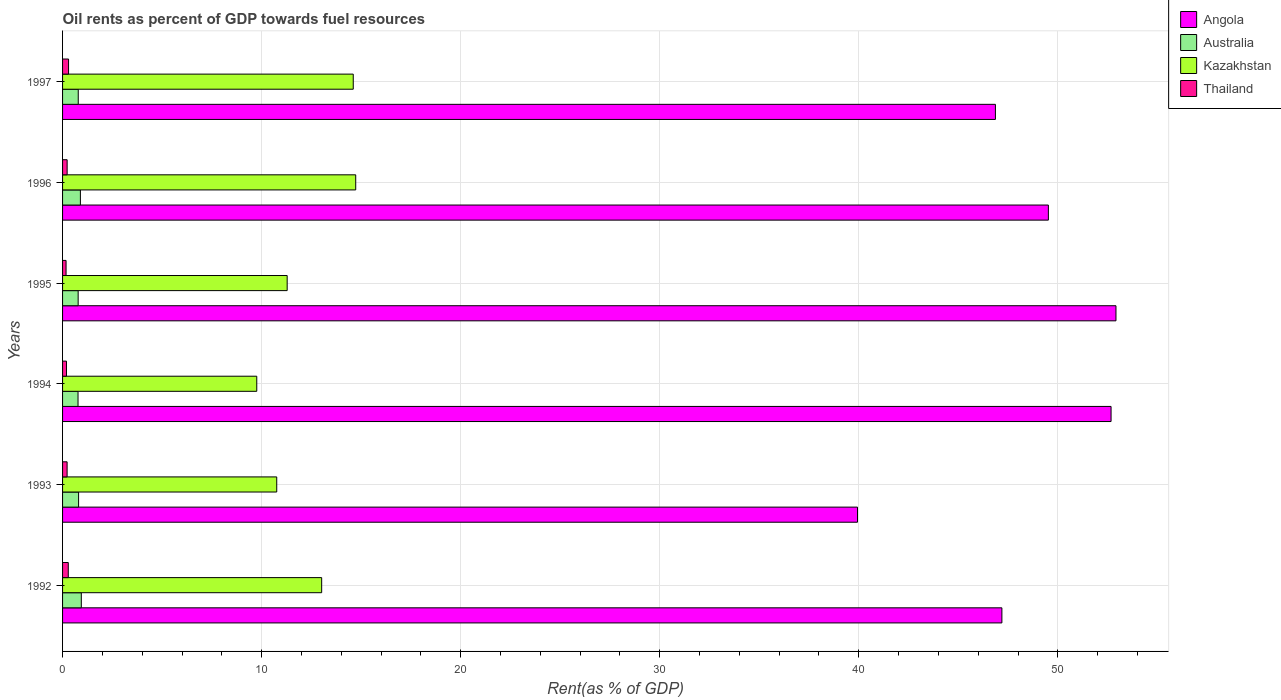How many bars are there on the 1st tick from the bottom?
Offer a very short reply. 4. In how many cases, is the number of bars for a given year not equal to the number of legend labels?
Your answer should be compact. 0. What is the oil rent in Kazakhstan in 1995?
Ensure brevity in your answer.  11.28. Across all years, what is the maximum oil rent in Thailand?
Offer a terse response. 0.3. Across all years, what is the minimum oil rent in Thailand?
Give a very brief answer. 0.18. What is the total oil rent in Thailand in the graph?
Ensure brevity in your answer.  1.42. What is the difference between the oil rent in Australia in 1996 and that in 1997?
Your answer should be compact. 0.11. What is the difference between the oil rent in Thailand in 1993 and the oil rent in Kazakhstan in 1995?
Offer a very short reply. -11.06. What is the average oil rent in Australia per year?
Your response must be concise. 0.83. In the year 1992, what is the difference between the oil rent in Thailand and oil rent in Kazakhstan?
Your answer should be very brief. -12.73. What is the ratio of the oil rent in Angola in 1995 to that in 1996?
Offer a very short reply. 1.07. Is the oil rent in Angola in 1994 less than that in 1995?
Provide a short and direct response. Yes. Is the difference between the oil rent in Thailand in 1994 and 1995 greater than the difference between the oil rent in Kazakhstan in 1994 and 1995?
Ensure brevity in your answer.  Yes. What is the difference between the highest and the second highest oil rent in Thailand?
Provide a succinct answer. 0.01. What is the difference between the highest and the lowest oil rent in Australia?
Your answer should be very brief. 0.16. In how many years, is the oil rent in Kazakhstan greater than the average oil rent in Kazakhstan taken over all years?
Your answer should be very brief. 3. Is the sum of the oil rent in Australia in 1995 and 1997 greater than the maximum oil rent in Angola across all years?
Your response must be concise. No. Is it the case that in every year, the sum of the oil rent in Australia and oil rent in Angola is greater than the sum of oil rent in Thailand and oil rent in Kazakhstan?
Your answer should be compact. Yes. What does the 2nd bar from the top in 1992 represents?
Keep it short and to the point. Kazakhstan. What does the 3rd bar from the bottom in 1994 represents?
Your response must be concise. Kazakhstan. How many bars are there?
Make the answer very short. 24. Are all the bars in the graph horizontal?
Your answer should be very brief. Yes. How many years are there in the graph?
Your answer should be compact. 6. Where does the legend appear in the graph?
Give a very brief answer. Top right. What is the title of the graph?
Provide a short and direct response. Oil rents as percent of GDP towards fuel resources. What is the label or title of the X-axis?
Provide a succinct answer. Rent(as % of GDP). What is the label or title of the Y-axis?
Make the answer very short. Years. What is the Rent(as % of GDP) in Angola in 1992?
Your response must be concise. 47.19. What is the Rent(as % of GDP) in Australia in 1992?
Your answer should be very brief. 0.94. What is the Rent(as % of GDP) of Kazakhstan in 1992?
Keep it short and to the point. 13.02. What is the Rent(as % of GDP) in Thailand in 1992?
Make the answer very short. 0.29. What is the Rent(as % of GDP) of Angola in 1993?
Provide a succinct answer. 39.94. What is the Rent(as % of GDP) of Australia in 1993?
Make the answer very short. 0.81. What is the Rent(as % of GDP) in Kazakhstan in 1993?
Your answer should be very brief. 10.76. What is the Rent(as % of GDP) in Thailand in 1993?
Give a very brief answer. 0.23. What is the Rent(as % of GDP) of Angola in 1994?
Your answer should be very brief. 52.68. What is the Rent(as % of GDP) of Australia in 1994?
Keep it short and to the point. 0.78. What is the Rent(as % of GDP) of Kazakhstan in 1994?
Make the answer very short. 9.76. What is the Rent(as % of GDP) in Thailand in 1994?
Provide a succinct answer. 0.2. What is the Rent(as % of GDP) in Angola in 1995?
Make the answer very short. 52.92. What is the Rent(as % of GDP) in Australia in 1995?
Keep it short and to the point. 0.78. What is the Rent(as % of GDP) in Kazakhstan in 1995?
Provide a short and direct response. 11.28. What is the Rent(as % of GDP) in Thailand in 1995?
Offer a terse response. 0.18. What is the Rent(as % of GDP) of Angola in 1996?
Your answer should be very brief. 49.53. What is the Rent(as % of GDP) of Australia in 1996?
Your response must be concise. 0.9. What is the Rent(as % of GDP) in Kazakhstan in 1996?
Your answer should be compact. 14.73. What is the Rent(as % of GDP) in Thailand in 1996?
Your answer should be compact. 0.23. What is the Rent(as % of GDP) of Angola in 1997?
Make the answer very short. 46.87. What is the Rent(as % of GDP) in Australia in 1997?
Offer a terse response. 0.79. What is the Rent(as % of GDP) in Kazakhstan in 1997?
Provide a short and direct response. 14.6. What is the Rent(as % of GDP) of Thailand in 1997?
Provide a succinct answer. 0.3. Across all years, what is the maximum Rent(as % of GDP) in Angola?
Provide a short and direct response. 52.92. Across all years, what is the maximum Rent(as % of GDP) of Australia?
Ensure brevity in your answer.  0.94. Across all years, what is the maximum Rent(as % of GDP) in Kazakhstan?
Give a very brief answer. 14.73. Across all years, what is the maximum Rent(as % of GDP) in Thailand?
Give a very brief answer. 0.3. Across all years, what is the minimum Rent(as % of GDP) of Angola?
Ensure brevity in your answer.  39.94. Across all years, what is the minimum Rent(as % of GDP) of Australia?
Provide a short and direct response. 0.78. Across all years, what is the minimum Rent(as % of GDP) in Kazakhstan?
Your answer should be compact. 9.76. Across all years, what is the minimum Rent(as % of GDP) in Thailand?
Provide a short and direct response. 0.18. What is the total Rent(as % of GDP) of Angola in the graph?
Keep it short and to the point. 289.11. What is the total Rent(as % of GDP) in Australia in the graph?
Provide a succinct answer. 4.99. What is the total Rent(as % of GDP) of Kazakhstan in the graph?
Provide a short and direct response. 74.15. What is the total Rent(as % of GDP) of Thailand in the graph?
Your answer should be compact. 1.42. What is the difference between the Rent(as % of GDP) of Angola in 1992 and that in 1993?
Offer a very short reply. 7.25. What is the difference between the Rent(as % of GDP) of Australia in 1992 and that in 1993?
Provide a short and direct response. 0.14. What is the difference between the Rent(as % of GDP) in Kazakhstan in 1992 and that in 1993?
Make the answer very short. 2.26. What is the difference between the Rent(as % of GDP) of Thailand in 1992 and that in 1993?
Give a very brief answer. 0.06. What is the difference between the Rent(as % of GDP) of Angola in 1992 and that in 1994?
Ensure brevity in your answer.  -5.48. What is the difference between the Rent(as % of GDP) of Australia in 1992 and that in 1994?
Make the answer very short. 0.16. What is the difference between the Rent(as % of GDP) in Kazakhstan in 1992 and that in 1994?
Provide a succinct answer. 3.26. What is the difference between the Rent(as % of GDP) of Thailand in 1992 and that in 1994?
Offer a very short reply. 0.09. What is the difference between the Rent(as % of GDP) of Angola in 1992 and that in 1995?
Keep it short and to the point. -5.73. What is the difference between the Rent(as % of GDP) of Australia in 1992 and that in 1995?
Provide a succinct answer. 0.16. What is the difference between the Rent(as % of GDP) of Kazakhstan in 1992 and that in 1995?
Provide a short and direct response. 1.73. What is the difference between the Rent(as % of GDP) of Thailand in 1992 and that in 1995?
Keep it short and to the point. 0.11. What is the difference between the Rent(as % of GDP) in Angola in 1992 and that in 1996?
Provide a succinct answer. -2.34. What is the difference between the Rent(as % of GDP) in Australia in 1992 and that in 1996?
Keep it short and to the point. 0.05. What is the difference between the Rent(as % of GDP) in Kazakhstan in 1992 and that in 1996?
Make the answer very short. -1.71. What is the difference between the Rent(as % of GDP) in Thailand in 1992 and that in 1996?
Offer a terse response. 0.06. What is the difference between the Rent(as % of GDP) in Angola in 1992 and that in 1997?
Offer a very short reply. 0.33. What is the difference between the Rent(as % of GDP) in Australia in 1992 and that in 1997?
Your answer should be compact. 0.15. What is the difference between the Rent(as % of GDP) in Kazakhstan in 1992 and that in 1997?
Provide a succinct answer. -1.59. What is the difference between the Rent(as % of GDP) of Thailand in 1992 and that in 1997?
Your response must be concise. -0.01. What is the difference between the Rent(as % of GDP) in Angola in 1993 and that in 1994?
Your answer should be very brief. -12.74. What is the difference between the Rent(as % of GDP) of Australia in 1993 and that in 1994?
Give a very brief answer. 0.03. What is the difference between the Rent(as % of GDP) in Thailand in 1993 and that in 1994?
Ensure brevity in your answer.  0.03. What is the difference between the Rent(as % of GDP) of Angola in 1993 and that in 1995?
Ensure brevity in your answer.  -12.98. What is the difference between the Rent(as % of GDP) in Australia in 1993 and that in 1995?
Offer a terse response. 0.02. What is the difference between the Rent(as % of GDP) of Kazakhstan in 1993 and that in 1995?
Provide a succinct answer. -0.52. What is the difference between the Rent(as % of GDP) in Thailand in 1993 and that in 1995?
Make the answer very short. 0.05. What is the difference between the Rent(as % of GDP) in Angola in 1993 and that in 1996?
Provide a short and direct response. -9.59. What is the difference between the Rent(as % of GDP) of Australia in 1993 and that in 1996?
Ensure brevity in your answer.  -0.09. What is the difference between the Rent(as % of GDP) of Kazakhstan in 1993 and that in 1996?
Your answer should be compact. -3.97. What is the difference between the Rent(as % of GDP) in Thailand in 1993 and that in 1996?
Offer a terse response. -0. What is the difference between the Rent(as % of GDP) in Angola in 1993 and that in 1997?
Your answer should be very brief. -6.93. What is the difference between the Rent(as % of GDP) of Australia in 1993 and that in 1997?
Offer a terse response. 0.02. What is the difference between the Rent(as % of GDP) of Kazakhstan in 1993 and that in 1997?
Give a very brief answer. -3.84. What is the difference between the Rent(as % of GDP) in Thailand in 1993 and that in 1997?
Keep it short and to the point. -0.07. What is the difference between the Rent(as % of GDP) of Angola in 1994 and that in 1995?
Provide a succinct answer. -0.25. What is the difference between the Rent(as % of GDP) in Australia in 1994 and that in 1995?
Ensure brevity in your answer.  -0.01. What is the difference between the Rent(as % of GDP) in Kazakhstan in 1994 and that in 1995?
Give a very brief answer. -1.53. What is the difference between the Rent(as % of GDP) of Thailand in 1994 and that in 1995?
Provide a short and direct response. 0.02. What is the difference between the Rent(as % of GDP) in Angola in 1994 and that in 1996?
Provide a succinct answer. 3.15. What is the difference between the Rent(as % of GDP) of Australia in 1994 and that in 1996?
Make the answer very short. -0.12. What is the difference between the Rent(as % of GDP) in Kazakhstan in 1994 and that in 1996?
Keep it short and to the point. -4.97. What is the difference between the Rent(as % of GDP) of Thailand in 1994 and that in 1996?
Keep it short and to the point. -0.03. What is the difference between the Rent(as % of GDP) in Angola in 1994 and that in 1997?
Offer a very short reply. 5.81. What is the difference between the Rent(as % of GDP) of Australia in 1994 and that in 1997?
Keep it short and to the point. -0.01. What is the difference between the Rent(as % of GDP) of Kazakhstan in 1994 and that in 1997?
Give a very brief answer. -4.85. What is the difference between the Rent(as % of GDP) of Thailand in 1994 and that in 1997?
Your response must be concise. -0.1. What is the difference between the Rent(as % of GDP) of Angola in 1995 and that in 1996?
Your answer should be compact. 3.4. What is the difference between the Rent(as % of GDP) in Australia in 1995 and that in 1996?
Your answer should be very brief. -0.11. What is the difference between the Rent(as % of GDP) of Kazakhstan in 1995 and that in 1996?
Your answer should be compact. -3.44. What is the difference between the Rent(as % of GDP) in Thailand in 1995 and that in 1996?
Ensure brevity in your answer.  -0.05. What is the difference between the Rent(as % of GDP) in Angola in 1995 and that in 1997?
Offer a very short reply. 6.06. What is the difference between the Rent(as % of GDP) in Australia in 1995 and that in 1997?
Offer a terse response. -0. What is the difference between the Rent(as % of GDP) in Kazakhstan in 1995 and that in 1997?
Make the answer very short. -3.32. What is the difference between the Rent(as % of GDP) of Thailand in 1995 and that in 1997?
Give a very brief answer. -0.13. What is the difference between the Rent(as % of GDP) in Angola in 1996 and that in 1997?
Provide a succinct answer. 2.66. What is the difference between the Rent(as % of GDP) in Australia in 1996 and that in 1997?
Provide a succinct answer. 0.11. What is the difference between the Rent(as % of GDP) of Kazakhstan in 1996 and that in 1997?
Your answer should be compact. 0.12. What is the difference between the Rent(as % of GDP) in Thailand in 1996 and that in 1997?
Make the answer very short. -0.07. What is the difference between the Rent(as % of GDP) in Angola in 1992 and the Rent(as % of GDP) in Australia in 1993?
Provide a succinct answer. 46.39. What is the difference between the Rent(as % of GDP) of Angola in 1992 and the Rent(as % of GDP) of Kazakhstan in 1993?
Your answer should be compact. 36.43. What is the difference between the Rent(as % of GDP) in Angola in 1992 and the Rent(as % of GDP) in Thailand in 1993?
Your answer should be compact. 46.96. What is the difference between the Rent(as % of GDP) of Australia in 1992 and the Rent(as % of GDP) of Kazakhstan in 1993?
Your response must be concise. -9.82. What is the difference between the Rent(as % of GDP) of Australia in 1992 and the Rent(as % of GDP) of Thailand in 1993?
Your answer should be very brief. 0.71. What is the difference between the Rent(as % of GDP) of Kazakhstan in 1992 and the Rent(as % of GDP) of Thailand in 1993?
Your answer should be compact. 12.79. What is the difference between the Rent(as % of GDP) of Angola in 1992 and the Rent(as % of GDP) of Australia in 1994?
Offer a terse response. 46.41. What is the difference between the Rent(as % of GDP) in Angola in 1992 and the Rent(as % of GDP) in Kazakhstan in 1994?
Your response must be concise. 37.43. What is the difference between the Rent(as % of GDP) in Angola in 1992 and the Rent(as % of GDP) in Thailand in 1994?
Provide a succinct answer. 46.99. What is the difference between the Rent(as % of GDP) in Australia in 1992 and the Rent(as % of GDP) in Kazakhstan in 1994?
Offer a terse response. -8.81. What is the difference between the Rent(as % of GDP) in Australia in 1992 and the Rent(as % of GDP) in Thailand in 1994?
Your response must be concise. 0.74. What is the difference between the Rent(as % of GDP) of Kazakhstan in 1992 and the Rent(as % of GDP) of Thailand in 1994?
Your answer should be very brief. 12.82. What is the difference between the Rent(as % of GDP) of Angola in 1992 and the Rent(as % of GDP) of Australia in 1995?
Offer a very short reply. 46.41. What is the difference between the Rent(as % of GDP) in Angola in 1992 and the Rent(as % of GDP) in Kazakhstan in 1995?
Provide a short and direct response. 35.91. What is the difference between the Rent(as % of GDP) of Angola in 1992 and the Rent(as % of GDP) of Thailand in 1995?
Provide a succinct answer. 47.02. What is the difference between the Rent(as % of GDP) in Australia in 1992 and the Rent(as % of GDP) in Kazakhstan in 1995?
Your answer should be compact. -10.34. What is the difference between the Rent(as % of GDP) of Australia in 1992 and the Rent(as % of GDP) of Thailand in 1995?
Offer a terse response. 0.77. What is the difference between the Rent(as % of GDP) in Kazakhstan in 1992 and the Rent(as % of GDP) in Thailand in 1995?
Provide a short and direct response. 12.84. What is the difference between the Rent(as % of GDP) of Angola in 1992 and the Rent(as % of GDP) of Australia in 1996?
Provide a succinct answer. 46.29. What is the difference between the Rent(as % of GDP) in Angola in 1992 and the Rent(as % of GDP) in Kazakhstan in 1996?
Provide a short and direct response. 32.46. What is the difference between the Rent(as % of GDP) of Angola in 1992 and the Rent(as % of GDP) of Thailand in 1996?
Ensure brevity in your answer.  46.96. What is the difference between the Rent(as % of GDP) of Australia in 1992 and the Rent(as % of GDP) of Kazakhstan in 1996?
Provide a short and direct response. -13.79. What is the difference between the Rent(as % of GDP) of Australia in 1992 and the Rent(as % of GDP) of Thailand in 1996?
Provide a short and direct response. 0.71. What is the difference between the Rent(as % of GDP) of Kazakhstan in 1992 and the Rent(as % of GDP) of Thailand in 1996?
Give a very brief answer. 12.79. What is the difference between the Rent(as % of GDP) of Angola in 1992 and the Rent(as % of GDP) of Australia in 1997?
Offer a very short reply. 46.4. What is the difference between the Rent(as % of GDP) in Angola in 1992 and the Rent(as % of GDP) in Kazakhstan in 1997?
Your answer should be compact. 32.59. What is the difference between the Rent(as % of GDP) in Angola in 1992 and the Rent(as % of GDP) in Thailand in 1997?
Offer a terse response. 46.89. What is the difference between the Rent(as % of GDP) in Australia in 1992 and the Rent(as % of GDP) in Kazakhstan in 1997?
Ensure brevity in your answer.  -13.66. What is the difference between the Rent(as % of GDP) of Australia in 1992 and the Rent(as % of GDP) of Thailand in 1997?
Make the answer very short. 0.64. What is the difference between the Rent(as % of GDP) of Kazakhstan in 1992 and the Rent(as % of GDP) of Thailand in 1997?
Provide a succinct answer. 12.72. What is the difference between the Rent(as % of GDP) in Angola in 1993 and the Rent(as % of GDP) in Australia in 1994?
Your response must be concise. 39.16. What is the difference between the Rent(as % of GDP) of Angola in 1993 and the Rent(as % of GDP) of Kazakhstan in 1994?
Ensure brevity in your answer.  30.18. What is the difference between the Rent(as % of GDP) of Angola in 1993 and the Rent(as % of GDP) of Thailand in 1994?
Your answer should be compact. 39.74. What is the difference between the Rent(as % of GDP) in Australia in 1993 and the Rent(as % of GDP) in Kazakhstan in 1994?
Make the answer very short. -8.95. What is the difference between the Rent(as % of GDP) in Australia in 1993 and the Rent(as % of GDP) in Thailand in 1994?
Ensure brevity in your answer.  0.61. What is the difference between the Rent(as % of GDP) of Kazakhstan in 1993 and the Rent(as % of GDP) of Thailand in 1994?
Keep it short and to the point. 10.56. What is the difference between the Rent(as % of GDP) of Angola in 1993 and the Rent(as % of GDP) of Australia in 1995?
Your answer should be very brief. 39.15. What is the difference between the Rent(as % of GDP) of Angola in 1993 and the Rent(as % of GDP) of Kazakhstan in 1995?
Keep it short and to the point. 28.65. What is the difference between the Rent(as % of GDP) in Angola in 1993 and the Rent(as % of GDP) in Thailand in 1995?
Ensure brevity in your answer.  39.76. What is the difference between the Rent(as % of GDP) of Australia in 1993 and the Rent(as % of GDP) of Kazakhstan in 1995?
Ensure brevity in your answer.  -10.48. What is the difference between the Rent(as % of GDP) in Australia in 1993 and the Rent(as % of GDP) in Thailand in 1995?
Your response must be concise. 0.63. What is the difference between the Rent(as % of GDP) of Kazakhstan in 1993 and the Rent(as % of GDP) of Thailand in 1995?
Your response must be concise. 10.58. What is the difference between the Rent(as % of GDP) in Angola in 1993 and the Rent(as % of GDP) in Australia in 1996?
Provide a short and direct response. 39.04. What is the difference between the Rent(as % of GDP) in Angola in 1993 and the Rent(as % of GDP) in Kazakhstan in 1996?
Your answer should be very brief. 25.21. What is the difference between the Rent(as % of GDP) in Angola in 1993 and the Rent(as % of GDP) in Thailand in 1996?
Keep it short and to the point. 39.71. What is the difference between the Rent(as % of GDP) in Australia in 1993 and the Rent(as % of GDP) in Kazakhstan in 1996?
Offer a very short reply. -13.92. What is the difference between the Rent(as % of GDP) of Australia in 1993 and the Rent(as % of GDP) of Thailand in 1996?
Ensure brevity in your answer.  0.57. What is the difference between the Rent(as % of GDP) of Kazakhstan in 1993 and the Rent(as % of GDP) of Thailand in 1996?
Your response must be concise. 10.53. What is the difference between the Rent(as % of GDP) of Angola in 1993 and the Rent(as % of GDP) of Australia in 1997?
Provide a short and direct response. 39.15. What is the difference between the Rent(as % of GDP) of Angola in 1993 and the Rent(as % of GDP) of Kazakhstan in 1997?
Make the answer very short. 25.33. What is the difference between the Rent(as % of GDP) of Angola in 1993 and the Rent(as % of GDP) of Thailand in 1997?
Your response must be concise. 39.64. What is the difference between the Rent(as % of GDP) in Australia in 1993 and the Rent(as % of GDP) in Kazakhstan in 1997?
Ensure brevity in your answer.  -13.8. What is the difference between the Rent(as % of GDP) of Australia in 1993 and the Rent(as % of GDP) of Thailand in 1997?
Give a very brief answer. 0.5. What is the difference between the Rent(as % of GDP) in Kazakhstan in 1993 and the Rent(as % of GDP) in Thailand in 1997?
Make the answer very short. 10.46. What is the difference between the Rent(as % of GDP) in Angola in 1994 and the Rent(as % of GDP) in Australia in 1995?
Offer a terse response. 51.89. What is the difference between the Rent(as % of GDP) of Angola in 1994 and the Rent(as % of GDP) of Kazakhstan in 1995?
Make the answer very short. 41.39. What is the difference between the Rent(as % of GDP) of Angola in 1994 and the Rent(as % of GDP) of Thailand in 1995?
Your answer should be very brief. 52.5. What is the difference between the Rent(as % of GDP) of Australia in 1994 and the Rent(as % of GDP) of Kazakhstan in 1995?
Your answer should be compact. -10.51. What is the difference between the Rent(as % of GDP) of Australia in 1994 and the Rent(as % of GDP) of Thailand in 1995?
Your response must be concise. 0.6. What is the difference between the Rent(as % of GDP) in Kazakhstan in 1994 and the Rent(as % of GDP) in Thailand in 1995?
Your answer should be compact. 9.58. What is the difference between the Rent(as % of GDP) in Angola in 1994 and the Rent(as % of GDP) in Australia in 1996?
Provide a short and direct response. 51.78. What is the difference between the Rent(as % of GDP) in Angola in 1994 and the Rent(as % of GDP) in Kazakhstan in 1996?
Provide a succinct answer. 37.95. What is the difference between the Rent(as % of GDP) of Angola in 1994 and the Rent(as % of GDP) of Thailand in 1996?
Ensure brevity in your answer.  52.45. What is the difference between the Rent(as % of GDP) of Australia in 1994 and the Rent(as % of GDP) of Kazakhstan in 1996?
Keep it short and to the point. -13.95. What is the difference between the Rent(as % of GDP) of Australia in 1994 and the Rent(as % of GDP) of Thailand in 1996?
Keep it short and to the point. 0.55. What is the difference between the Rent(as % of GDP) in Kazakhstan in 1994 and the Rent(as % of GDP) in Thailand in 1996?
Make the answer very short. 9.53. What is the difference between the Rent(as % of GDP) of Angola in 1994 and the Rent(as % of GDP) of Australia in 1997?
Offer a very short reply. 51.89. What is the difference between the Rent(as % of GDP) of Angola in 1994 and the Rent(as % of GDP) of Kazakhstan in 1997?
Your answer should be very brief. 38.07. What is the difference between the Rent(as % of GDP) of Angola in 1994 and the Rent(as % of GDP) of Thailand in 1997?
Your response must be concise. 52.37. What is the difference between the Rent(as % of GDP) of Australia in 1994 and the Rent(as % of GDP) of Kazakhstan in 1997?
Offer a terse response. -13.83. What is the difference between the Rent(as % of GDP) in Australia in 1994 and the Rent(as % of GDP) in Thailand in 1997?
Your answer should be compact. 0.48. What is the difference between the Rent(as % of GDP) of Kazakhstan in 1994 and the Rent(as % of GDP) of Thailand in 1997?
Ensure brevity in your answer.  9.46. What is the difference between the Rent(as % of GDP) of Angola in 1995 and the Rent(as % of GDP) of Australia in 1996?
Keep it short and to the point. 52.03. What is the difference between the Rent(as % of GDP) in Angola in 1995 and the Rent(as % of GDP) in Kazakhstan in 1996?
Keep it short and to the point. 38.19. What is the difference between the Rent(as % of GDP) in Angola in 1995 and the Rent(as % of GDP) in Thailand in 1996?
Keep it short and to the point. 52.69. What is the difference between the Rent(as % of GDP) of Australia in 1995 and the Rent(as % of GDP) of Kazakhstan in 1996?
Keep it short and to the point. -13.94. What is the difference between the Rent(as % of GDP) in Australia in 1995 and the Rent(as % of GDP) in Thailand in 1996?
Your answer should be very brief. 0.55. What is the difference between the Rent(as % of GDP) of Kazakhstan in 1995 and the Rent(as % of GDP) of Thailand in 1996?
Offer a very short reply. 11.05. What is the difference between the Rent(as % of GDP) of Angola in 1995 and the Rent(as % of GDP) of Australia in 1997?
Keep it short and to the point. 52.13. What is the difference between the Rent(as % of GDP) in Angola in 1995 and the Rent(as % of GDP) in Kazakhstan in 1997?
Make the answer very short. 38.32. What is the difference between the Rent(as % of GDP) of Angola in 1995 and the Rent(as % of GDP) of Thailand in 1997?
Your answer should be very brief. 52.62. What is the difference between the Rent(as % of GDP) of Australia in 1995 and the Rent(as % of GDP) of Kazakhstan in 1997?
Keep it short and to the point. -13.82. What is the difference between the Rent(as % of GDP) in Australia in 1995 and the Rent(as % of GDP) in Thailand in 1997?
Your answer should be very brief. 0.48. What is the difference between the Rent(as % of GDP) in Kazakhstan in 1995 and the Rent(as % of GDP) in Thailand in 1997?
Keep it short and to the point. 10.98. What is the difference between the Rent(as % of GDP) in Angola in 1996 and the Rent(as % of GDP) in Australia in 1997?
Offer a terse response. 48.74. What is the difference between the Rent(as % of GDP) of Angola in 1996 and the Rent(as % of GDP) of Kazakhstan in 1997?
Your response must be concise. 34.92. What is the difference between the Rent(as % of GDP) in Angola in 1996 and the Rent(as % of GDP) in Thailand in 1997?
Give a very brief answer. 49.22. What is the difference between the Rent(as % of GDP) in Australia in 1996 and the Rent(as % of GDP) in Kazakhstan in 1997?
Your response must be concise. -13.71. What is the difference between the Rent(as % of GDP) of Australia in 1996 and the Rent(as % of GDP) of Thailand in 1997?
Make the answer very short. 0.59. What is the difference between the Rent(as % of GDP) in Kazakhstan in 1996 and the Rent(as % of GDP) in Thailand in 1997?
Give a very brief answer. 14.43. What is the average Rent(as % of GDP) in Angola per year?
Ensure brevity in your answer.  48.19. What is the average Rent(as % of GDP) of Australia per year?
Your response must be concise. 0.83. What is the average Rent(as % of GDP) of Kazakhstan per year?
Ensure brevity in your answer.  12.36. What is the average Rent(as % of GDP) of Thailand per year?
Provide a short and direct response. 0.24. In the year 1992, what is the difference between the Rent(as % of GDP) of Angola and Rent(as % of GDP) of Australia?
Provide a short and direct response. 46.25. In the year 1992, what is the difference between the Rent(as % of GDP) of Angola and Rent(as % of GDP) of Kazakhstan?
Give a very brief answer. 34.17. In the year 1992, what is the difference between the Rent(as % of GDP) of Angola and Rent(as % of GDP) of Thailand?
Provide a succinct answer. 46.9. In the year 1992, what is the difference between the Rent(as % of GDP) of Australia and Rent(as % of GDP) of Kazakhstan?
Your response must be concise. -12.08. In the year 1992, what is the difference between the Rent(as % of GDP) in Australia and Rent(as % of GDP) in Thailand?
Your answer should be very brief. 0.66. In the year 1992, what is the difference between the Rent(as % of GDP) in Kazakhstan and Rent(as % of GDP) in Thailand?
Provide a succinct answer. 12.73. In the year 1993, what is the difference between the Rent(as % of GDP) of Angola and Rent(as % of GDP) of Australia?
Make the answer very short. 39.13. In the year 1993, what is the difference between the Rent(as % of GDP) in Angola and Rent(as % of GDP) in Kazakhstan?
Your response must be concise. 29.18. In the year 1993, what is the difference between the Rent(as % of GDP) in Angola and Rent(as % of GDP) in Thailand?
Provide a short and direct response. 39.71. In the year 1993, what is the difference between the Rent(as % of GDP) of Australia and Rent(as % of GDP) of Kazakhstan?
Offer a terse response. -9.95. In the year 1993, what is the difference between the Rent(as % of GDP) in Australia and Rent(as % of GDP) in Thailand?
Ensure brevity in your answer.  0.58. In the year 1993, what is the difference between the Rent(as % of GDP) in Kazakhstan and Rent(as % of GDP) in Thailand?
Your answer should be very brief. 10.53. In the year 1994, what is the difference between the Rent(as % of GDP) in Angola and Rent(as % of GDP) in Australia?
Your answer should be very brief. 51.9. In the year 1994, what is the difference between the Rent(as % of GDP) of Angola and Rent(as % of GDP) of Kazakhstan?
Ensure brevity in your answer.  42.92. In the year 1994, what is the difference between the Rent(as % of GDP) of Angola and Rent(as % of GDP) of Thailand?
Provide a succinct answer. 52.48. In the year 1994, what is the difference between the Rent(as % of GDP) in Australia and Rent(as % of GDP) in Kazakhstan?
Give a very brief answer. -8.98. In the year 1994, what is the difference between the Rent(as % of GDP) in Australia and Rent(as % of GDP) in Thailand?
Keep it short and to the point. 0.58. In the year 1994, what is the difference between the Rent(as % of GDP) of Kazakhstan and Rent(as % of GDP) of Thailand?
Give a very brief answer. 9.56. In the year 1995, what is the difference between the Rent(as % of GDP) in Angola and Rent(as % of GDP) in Australia?
Make the answer very short. 52.14. In the year 1995, what is the difference between the Rent(as % of GDP) of Angola and Rent(as % of GDP) of Kazakhstan?
Ensure brevity in your answer.  41.64. In the year 1995, what is the difference between the Rent(as % of GDP) in Angola and Rent(as % of GDP) in Thailand?
Keep it short and to the point. 52.75. In the year 1995, what is the difference between the Rent(as % of GDP) of Australia and Rent(as % of GDP) of Kazakhstan?
Provide a short and direct response. -10.5. In the year 1995, what is the difference between the Rent(as % of GDP) in Australia and Rent(as % of GDP) in Thailand?
Keep it short and to the point. 0.61. In the year 1995, what is the difference between the Rent(as % of GDP) of Kazakhstan and Rent(as % of GDP) of Thailand?
Provide a succinct answer. 11.11. In the year 1996, what is the difference between the Rent(as % of GDP) in Angola and Rent(as % of GDP) in Australia?
Give a very brief answer. 48.63. In the year 1996, what is the difference between the Rent(as % of GDP) of Angola and Rent(as % of GDP) of Kazakhstan?
Give a very brief answer. 34.8. In the year 1996, what is the difference between the Rent(as % of GDP) of Angola and Rent(as % of GDP) of Thailand?
Your answer should be compact. 49.3. In the year 1996, what is the difference between the Rent(as % of GDP) in Australia and Rent(as % of GDP) in Kazakhstan?
Give a very brief answer. -13.83. In the year 1996, what is the difference between the Rent(as % of GDP) of Australia and Rent(as % of GDP) of Thailand?
Provide a short and direct response. 0.67. In the year 1996, what is the difference between the Rent(as % of GDP) of Kazakhstan and Rent(as % of GDP) of Thailand?
Provide a succinct answer. 14.5. In the year 1997, what is the difference between the Rent(as % of GDP) in Angola and Rent(as % of GDP) in Australia?
Give a very brief answer. 46.08. In the year 1997, what is the difference between the Rent(as % of GDP) in Angola and Rent(as % of GDP) in Kazakhstan?
Ensure brevity in your answer.  32.26. In the year 1997, what is the difference between the Rent(as % of GDP) of Angola and Rent(as % of GDP) of Thailand?
Your response must be concise. 46.56. In the year 1997, what is the difference between the Rent(as % of GDP) of Australia and Rent(as % of GDP) of Kazakhstan?
Offer a very short reply. -13.82. In the year 1997, what is the difference between the Rent(as % of GDP) of Australia and Rent(as % of GDP) of Thailand?
Keep it short and to the point. 0.49. In the year 1997, what is the difference between the Rent(as % of GDP) in Kazakhstan and Rent(as % of GDP) in Thailand?
Keep it short and to the point. 14.3. What is the ratio of the Rent(as % of GDP) in Angola in 1992 to that in 1993?
Provide a short and direct response. 1.18. What is the ratio of the Rent(as % of GDP) of Australia in 1992 to that in 1993?
Your answer should be compact. 1.17. What is the ratio of the Rent(as % of GDP) of Kazakhstan in 1992 to that in 1993?
Provide a succinct answer. 1.21. What is the ratio of the Rent(as % of GDP) in Thailand in 1992 to that in 1993?
Give a very brief answer. 1.26. What is the ratio of the Rent(as % of GDP) of Angola in 1992 to that in 1994?
Keep it short and to the point. 0.9. What is the ratio of the Rent(as % of GDP) of Australia in 1992 to that in 1994?
Your response must be concise. 1.21. What is the ratio of the Rent(as % of GDP) in Kazakhstan in 1992 to that in 1994?
Ensure brevity in your answer.  1.33. What is the ratio of the Rent(as % of GDP) of Thailand in 1992 to that in 1994?
Ensure brevity in your answer.  1.46. What is the ratio of the Rent(as % of GDP) in Angola in 1992 to that in 1995?
Your answer should be compact. 0.89. What is the ratio of the Rent(as % of GDP) in Australia in 1992 to that in 1995?
Ensure brevity in your answer.  1.2. What is the ratio of the Rent(as % of GDP) in Kazakhstan in 1992 to that in 1995?
Ensure brevity in your answer.  1.15. What is the ratio of the Rent(as % of GDP) in Thailand in 1992 to that in 1995?
Give a very brief answer. 1.64. What is the ratio of the Rent(as % of GDP) in Angola in 1992 to that in 1996?
Offer a terse response. 0.95. What is the ratio of the Rent(as % of GDP) in Australia in 1992 to that in 1996?
Your answer should be compact. 1.05. What is the ratio of the Rent(as % of GDP) of Kazakhstan in 1992 to that in 1996?
Your answer should be very brief. 0.88. What is the ratio of the Rent(as % of GDP) in Thailand in 1992 to that in 1996?
Your response must be concise. 1.25. What is the ratio of the Rent(as % of GDP) of Angola in 1992 to that in 1997?
Give a very brief answer. 1.01. What is the ratio of the Rent(as % of GDP) in Australia in 1992 to that in 1997?
Your answer should be compact. 1.19. What is the ratio of the Rent(as % of GDP) of Kazakhstan in 1992 to that in 1997?
Provide a short and direct response. 0.89. What is the ratio of the Rent(as % of GDP) in Thailand in 1992 to that in 1997?
Offer a very short reply. 0.95. What is the ratio of the Rent(as % of GDP) of Angola in 1993 to that in 1994?
Provide a succinct answer. 0.76. What is the ratio of the Rent(as % of GDP) of Australia in 1993 to that in 1994?
Provide a short and direct response. 1.04. What is the ratio of the Rent(as % of GDP) in Kazakhstan in 1993 to that in 1994?
Keep it short and to the point. 1.1. What is the ratio of the Rent(as % of GDP) in Thailand in 1993 to that in 1994?
Your answer should be very brief. 1.16. What is the ratio of the Rent(as % of GDP) in Angola in 1993 to that in 1995?
Make the answer very short. 0.75. What is the ratio of the Rent(as % of GDP) of Australia in 1993 to that in 1995?
Your answer should be very brief. 1.03. What is the ratio of the Rent(as % of GDP) of Kazakhstan in 1993 to that in 1995?
Ensure brevity in your answer.  0.95. What is the ratio of the Rent(as % of GDP) in Thailand in 1993 to that in 1995?
Give a very brief answer. 1.3. What is the ratio of the Rent(as % of GDP) in Angola in 1993 to that in 1996?
Make the answer very short. 0.81. What is the ratio of the Rent(as % of GDP) of Australia in 1993 to that in 1996?
Ensure brevity in your answer.  0.9. What is the ratio of the Rent(as % of GDP) of Kazakhstan in 1993 to that in 1996?
Give a very brief answer. 0.73. What is the ratio of the Rent(as % of GDP) of Thailand in 1993 to that in 1996?
Make the answer very short. 0.99. What is the ratio of the Rent(as % of GDP) of Angola in 1993 to that in 1997?
Your response must be concise. 0.85. What is the ratio of the Rent(as % of GDP) of Australia in 1993 to that in 1997?
Make the answer very short. 1.02. What is the ratio of the Rent(as % of GDP) in Kazakhstan in 1993 to that in 1997?
Make the answer very short. 0.74. What is the ratio of the Rent(as % of GDP) in Thailand in 1993 to that in 1997?
Ensure brevity in your answer.  0.76. What is the ratio of the Rent(as % of GDP) in Kazakhstan in 1994 to that in 1995?
Your response must be concise. 0.86. What is the ratio of the Rent(as % of GDP) of Thailand in 1994 to that in 1995?
Ensure brevity in your answer.  1.12. What is the ratio of the Rent(as % of GDP) of Angola in 1994 to that in 1996?
Your answer should be very brief. 1.06. What is the ratio of the Rent(as % of GDP) of Australia in 1994 to that in 1996?
Your response must be concise. 0.87. What is the ratio of the Rent(as % of GDP) in Kazakhstan in 1994 to that in 1996?
Make the answer very short. 0.66. What is the ratio of the Rent(as % of GDP) of Thailand in 1994 to that in 1996?
Make the answer very short. 0.86. What is the ratio of the Rent(as % of GDP) in Angola in 1994 to that in 1997?
Keep it short and to the point. 1.12. What is the ratio of the Rent(as % of GDP) of Australia in 1994 to that in 1997?
Provide a succinct answer. 0.99. What is the ratio of the Rent(as % of GDP) in Kazakhstan in 1994 to that in 1997?
Provide a succinct answer. 0.67. What is the ratio of the Rent(as % of GDP) in Thailand in 1994 to that in 1997?
Make the answer very short. 0.65. What is the ratio of the Rent(as % of GDP) of Angola in 1995 to that in 1996?
Offer a terse response. 1.07. What is the ratio of the Rent(as % of GDP) of Australia in 1995 to that in 1996?
Ensure brevity in your answer.  0.87. What is the ratio of the Rent(as % of GDP) of Kazakhstan in 1995 to that in 1996?
Give a very brief answer. 0.77. What is the ratio of the Rent(as % of GDP) of Thailand in 1995 to that in 1996?
Keep it short and to the point. 0.76. What is the ratio of the Rent(as % of GDP) of Angola in 1995 to that in 1997?
Your answer should be compact. 1.13. What is the ratio of the Rent(as % of GDP) in Australia in 1995 to that in 1997?
Your answer should be compact. 0.99. What is the ratio of the Rent(as % of GDP) of Kazakhstan in 1995 to that in 1997?
Offer a very short reply. 0.77. What is the ratio of the Rent(as % of GDP) of Thailand in 1995 to that in 1997?
Ensure brevity in your answer.  0.58. What is the ratio of the Rent(as % of GDP) of Angola in 1996 to that in 1997?
Your answer should be very brief. 1.06. What is the ratio of the Rent(as % of GDP) in Australia in 1996 to that in 1997?
Give a very brief answer. 1.14. What is the ratio of the Rent(as % of GDP) in Kazakhstan in 1996 to that in 1997?
Ensure brevity in your answer.  1.01. What is the ratio of the Rent(as % of GDP) of Thailand in 1996 to that in 1997?
Ensure brevity in your answer.  0.76. What is the difference between the highest and the second highest Rent(as % of GDP) in Angola?
Ensure brevity in your answer.  0.25. What is the difference between the highest and the second highest Rent(as % of GDP) of Australia?
Make the answer very short. 0.05. What is the difference between the highest and the second highest Rent(as % of GDP) of Kazakhstan?
Offer a terse response. 0.12. What is the difference between the highest and the second highest Rent(as % of GDP) of Thailand?
Give a very brief answer. 0.01. What is the difference between the highest and the lowest Rent(as % of GDP) of Angola?
Your answer should be very brief. 12.98. What is the difference between the highest and the lowest Rent(as % of GDP) of Australia?
Offer a terse response. 0.16. What is the difference between the highest and the lowest Rent(as % of GDP) in Kazakhstan?
Offer a very short reply. 4.97. What is the difference between the highest and the lowest Rent(as % of GDP) in Thailand?
Keep it short and to the point. 0.13. 